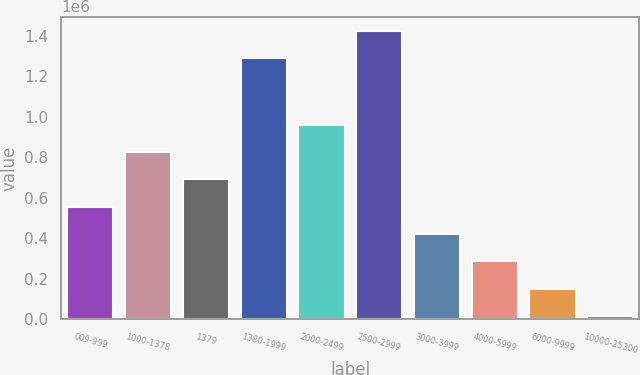<chart> <loc_0><loc_0><loc_500><loc_500><bar_chart><fcel>009-999<fcel>1000-1378<fcel>1379<fcel>1380-1999<fcel>2000-2499<fcel>2500-2999<fcel>3000-3999<fcel>4000-5999<fcel>6000-9999<fcel>10000-25300<nl><fcel>555529<fcel>824966<fcel>690248<fcel>1.28897e+06<fcel>959685<fcel>1.42369e+06<fcel>420810<fcel>286091<fcel>151373<fcel>16654<nl></chart> 